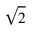<formula> <loc_0><loc_0><loc_500><loc_500>\sqrt { 2 }</formula> 